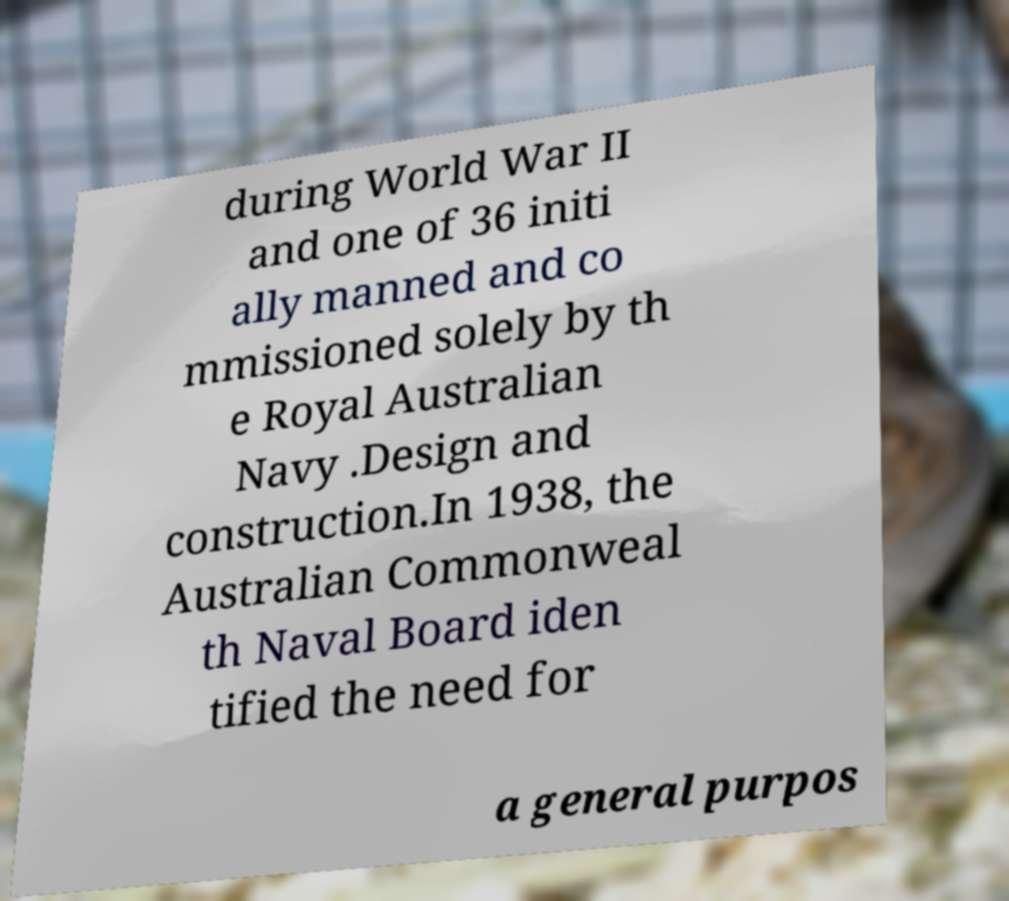I need the written content from this picture converted into text. Can you do that? during World War II and one of 36 initi ally manned and co mmissioned solely by th e Royal Australian Navy .Design and construction.In 1938, the Australian Commonweal th Naval Board iden tified the need for a general purpos 